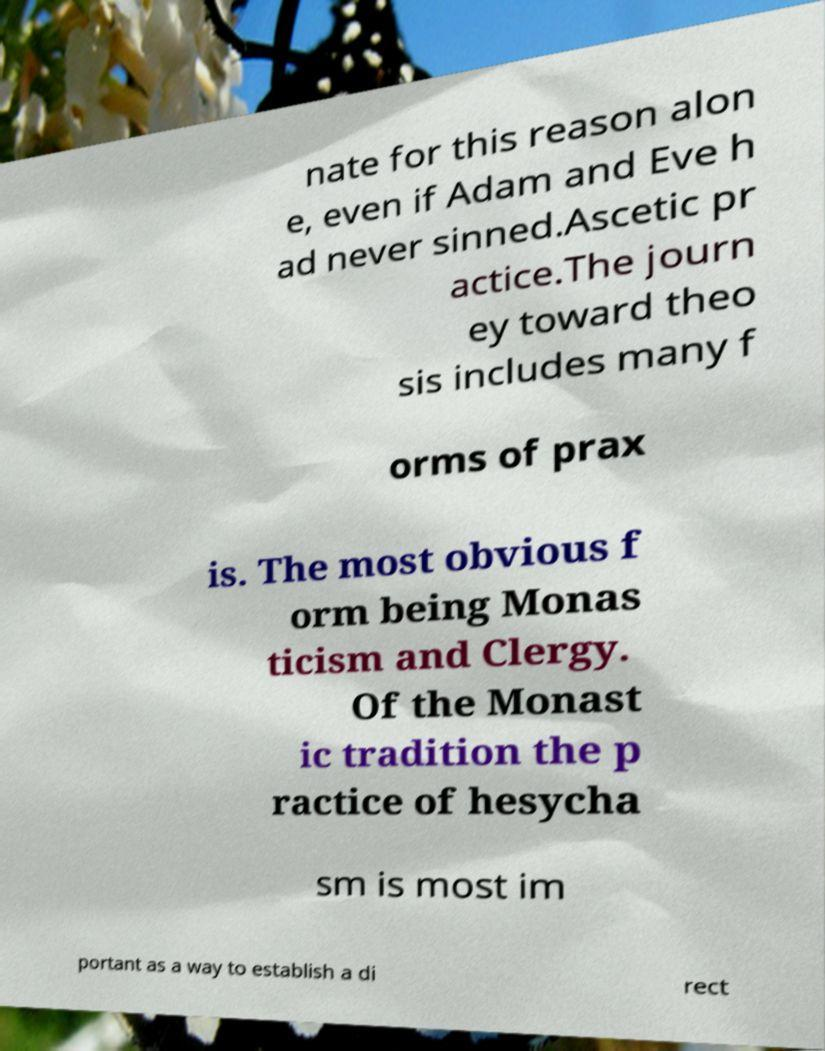For documentation purposes, I need the text within this image transcribed. Could you provide that? nate for this reason alon e, even if Adam and Eve h ad never sinned.Ascetic pr actice.The journ ey toward theo sis includes many f orms of prax is. The most obvious f orm being Monas ticism and Clergy. Of the Monast ic tradition the p ractice of hesycha sm is most im portant as a way to establish a di rect 